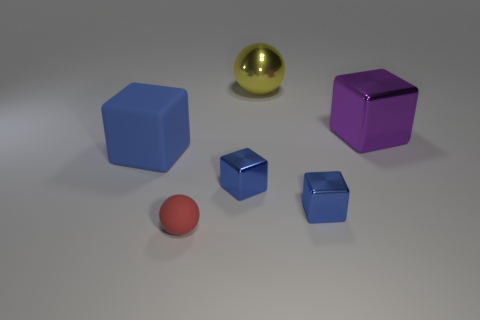Does the big cube right of the big yellow sphere have the same material as the sphere in front of the large blue thing?
Provide a short and direct response. No. The purple shiny thing that is behind the rubber cube has what shape?
Give a very brief answer. Cube. How many objects are either small blue metal objects or objects on the right side of the big yellow sphere?
Offer a terse response. 3. Are the large sphere and the purple block made of the same material?
Offer a very short reply. Yes. Are there an equal number of yellow objects behind the yellow shiny thing and rubber objects that are to the left of the big purple metallic thing?
Make the answer very short. No. There is a small rubber thing; how many blue things are behind it?
Keep it short and to the point. 3. What number of things are blue shiny blocks or big blue matte blocks?
Give a very brief answer. 3. How many blue cubes have the same size as the red ball?
Your answer should be very brief. 2. What is the shape of the rubber thing that is to the right of the blue thing that is on the left side of the small red object?
Your response must be concise. Sphere. Are there fewer blue metal blocks than tiny brown shiny objects?
Provide a short and direct response. No. 